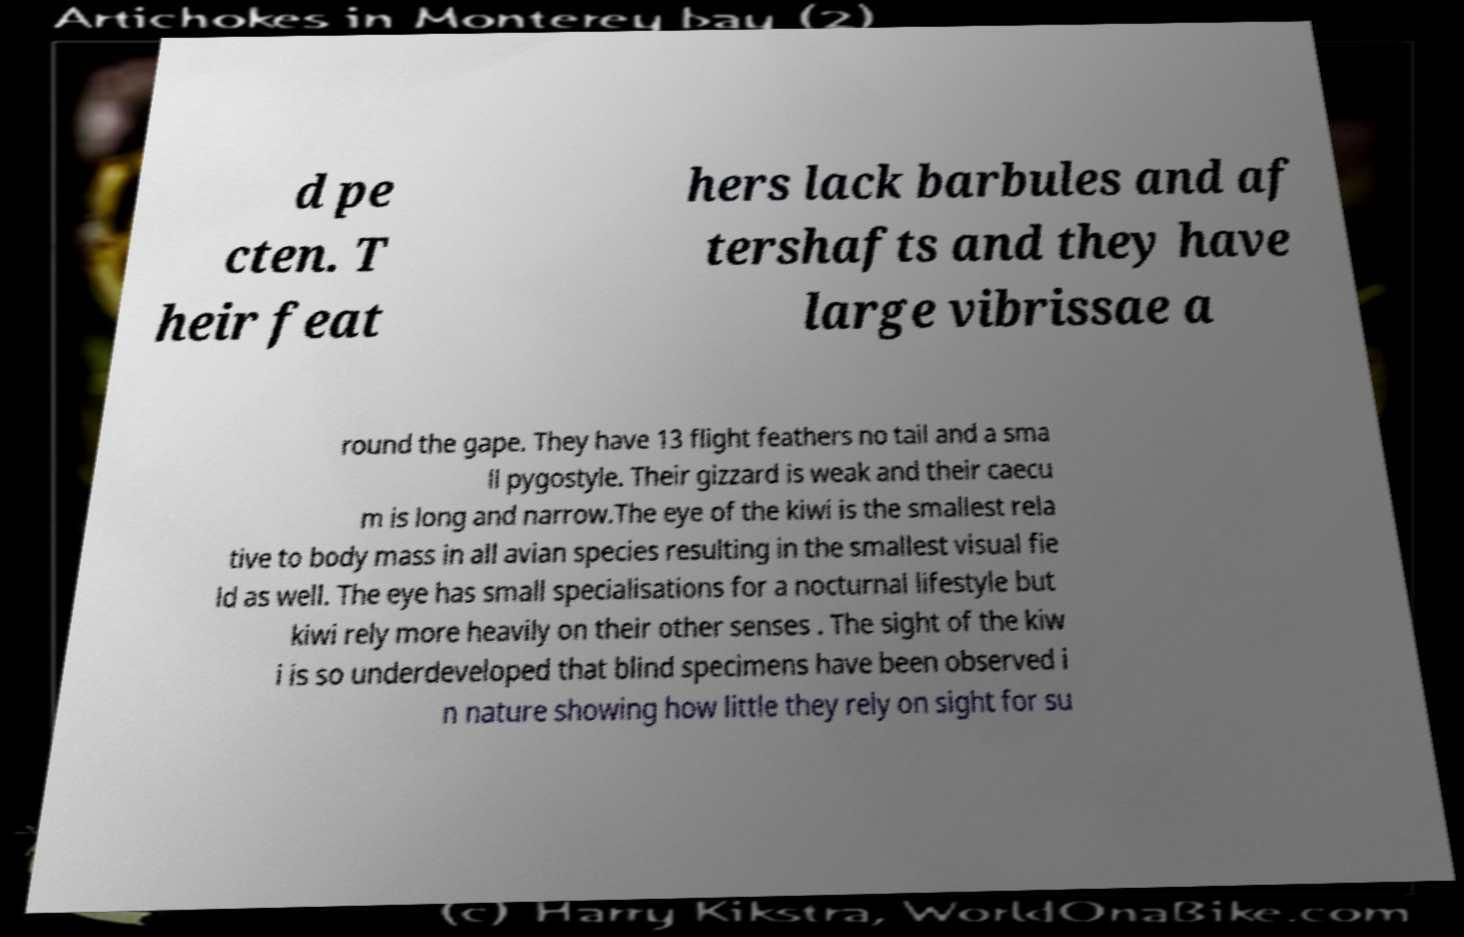Could you assist in decoding the text presented in this image and type it out clearly? d pe cten. T heir feat hers lack barbules and af tershafts and they have large vibrissae a round the gape. They have 13 flight feathers no tail and a sma ll pygostyle. Their gizzard is weak and their caecu m is long and narrow.The eye of the kiwi is the smallest rela tive to body mass in all avian species resulting in the smallest visual fie ld as well. The eye has small specialisations for a nocturnal lifestyle but kiwi rely more heavily on their other senses . The sight of the kiw i is so underdeveloped that blind specimens have been observed i n nature showing how little they rely on sight for su 